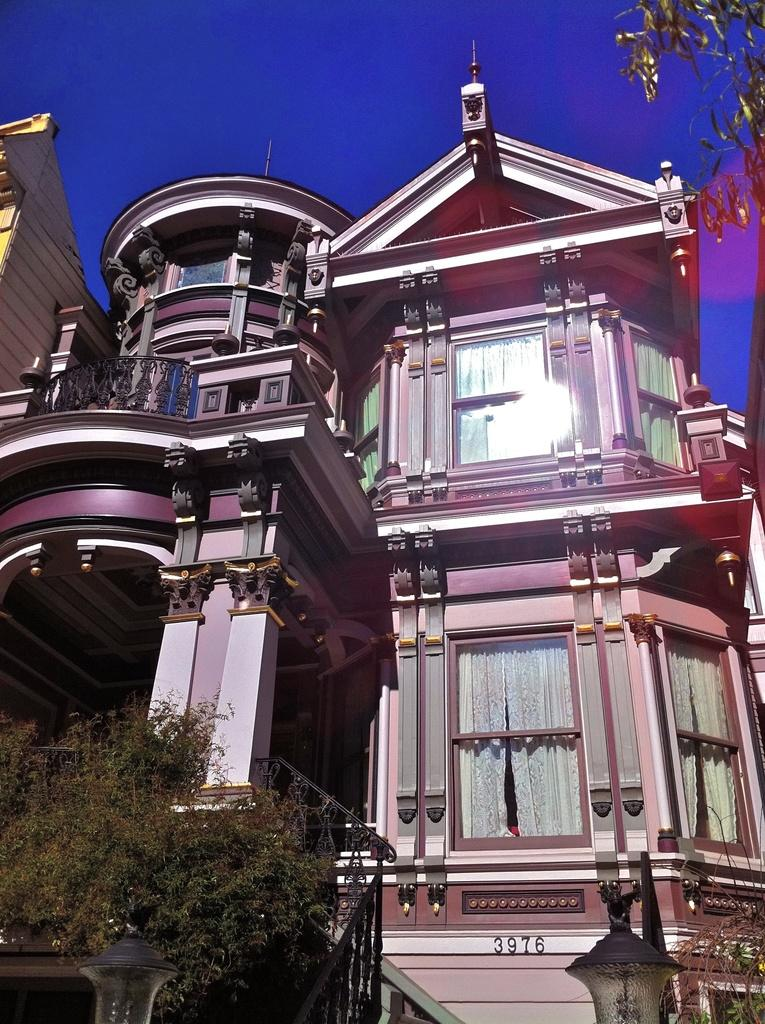What type of structure is present in the image? There is a building in the image. What is the color of the building? The building is brown in color. What can be seen at the bottom left of the image? There is a tree at the bottom left of the image. What is visible in the background of the image? The sky is visible in the image. What is the color of the sky? The sky is blue in color. Can you tell me how many squirrels are climbing on the building in the image? There are no squirrels present in the image; it only features a brown building, a tree, and a blue sky. 